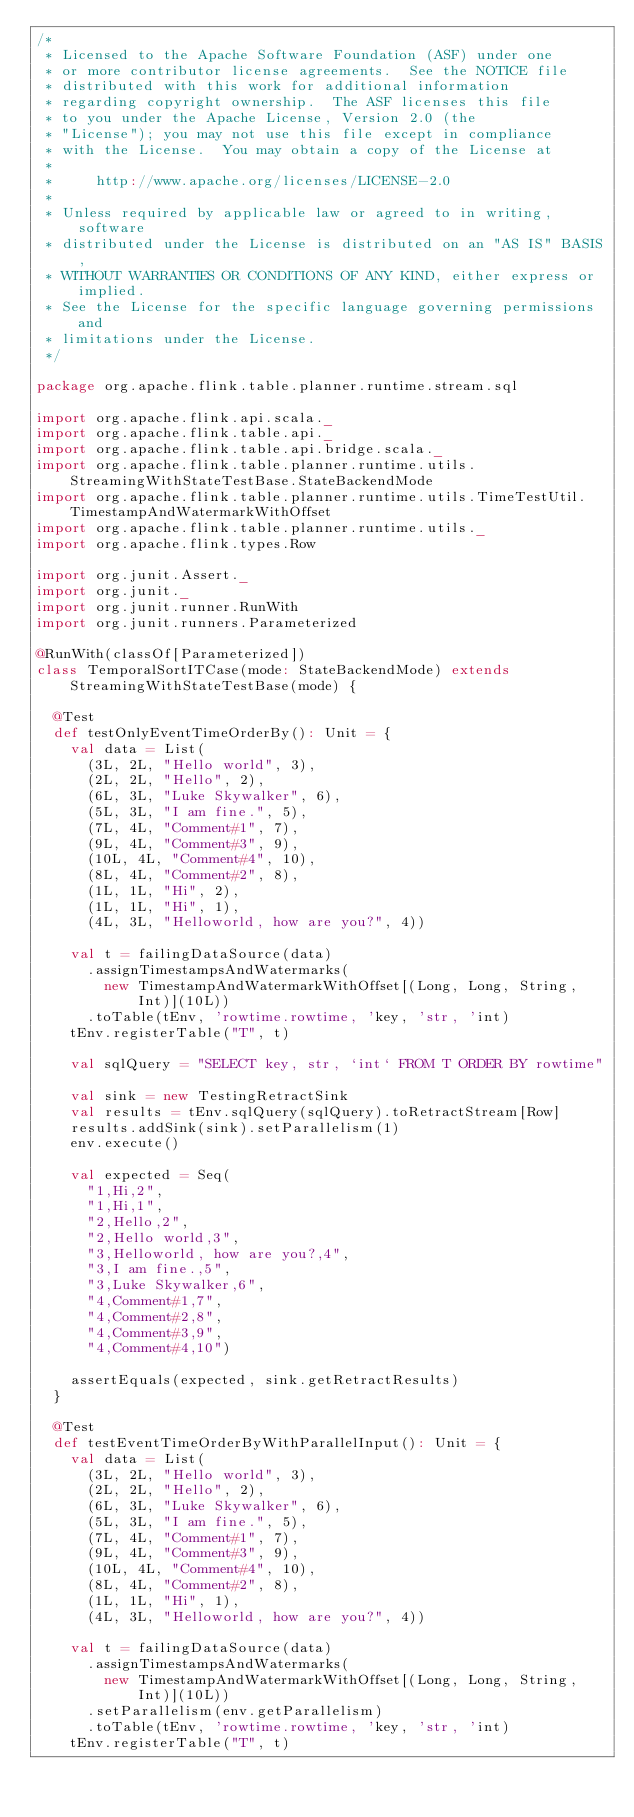<code> <loc_0><loc_0><loc_500><loc_500><_Scala_>/*
 * Licensed to the Apache Software Foundation (ASF) under one
 * or more contributor license agreements.  See the NOTICE file
 * distributed with this work for additional information
 * regarding copyright ownership.  The ASF licenses this file
 * to you under the Apache License, Version 2.0 (the
 * "License"); you may not use this file except in compliance
 * with the License.  You may obtain a copy of the License at
 *
 *     http://www.apache.org/licenses/LICENSE-2.0
 *
 * Unless required by applicable law or agreed to in writing, software
 * distributed under the License is distributed on an "AS IS" BASIS,
 * WITHOUT WARRANTIES OR CONDITIONS OF ANY KIND, either express or implied.
 * See the License for the specific language governing permissions and
 * limitations under the License.
 */

package org.apache.flink.table.planner.runtime.stream.sql

import org.apache.flink.api.scala._
import org.apache.flink.table.api._
import org.apache.flink.table.api.bridge.scala._
import org.apache.flink.table.planner.runtime.utils.StreamingWithStateTestBase.StateBackendMode
import org.apache.flink.table.planner.runtime.utils.TimeTestUtil.TimestampAndWatermarkWithOffset
import org.apache.flink.table.planner.runtime.utils._
import org.apache.flink.types.Row

import org.junit.Assert._
import org.junit._
import org.junit.runner.RunWith
import org.junit.runners.Parameterized

@RunWith(classOf[Parameterized])
class TemporalSortITCase(mode: StateBackendMode) extends StreamingWithStateTestBase(mode) {

  @Test
  def testOnlyEventTimeOrderBy(): Unit = {
    val data = List(
      (3L, 2L, "Hello world", 3),
      (2L, 2L, "Hello", 2),
      (6L, 3L, "Luke Skywalker", 6),
      (5L, 3L, "I am fine.", 5),
      (7L, 4L, "Comment#1", 7),
      (9L, 4L, "Comment#3", 9),
      (10L, 4L, "Comment#4", 10),
      (8L, 4L, "Comment#2", 8),
      (1L, 1L, "Hi", 2),
      (1L, 1L, "Hi", 1),
      (4L, 3L, "Helloworld, how are you?", 4))

    val t = failingDataSource(data)
      .assignTimestampsAndWatermarks(
        new TimestampAndWatermarkWithOffset[(Long, Long, String, Int)](10L))
      .toTable(tEnv, 'rowtime.rowtime, 'key, 'str, 'int)
    tEnv.registerTable("T", t)

    val sqlQuery = "SELECT key, str, `int` FROM T ORDER BY rowtime"

    val sink = new TestingRetractSink
    val results = tEnv.sqlQuery(sqlQuery).toRetractStream[Row]
    results.addSink(sink).setParallelism(1)
    env.execute()

    val expected = Seq(
      "1,Hi,2",
      "1,Hi,1",
      "2,Hello,2",
      "2,Hello world,3",
      "3,Helloworld, how are you?,4",
      "3,I am fine.,5",
      "3,Luke Skywalker,6",
      "4,Comment#1,7",
      "4,Comment#2,8",
      "4,Comment#3,9",
      "4,Comment#4,10")

    assertEquals(expected, sink.getRetractResults)
  }

  @Test
  def testEventTimeOrderByWithParallelInput(): Unit = {
    val data = List(
      (3L, 2L, "Hello world", 3),
      (2L, 2L, "Hello", 2),
      (6L, 3L, "Luke Skywalker", 6),
      (5L, 3L, "I am fine.", 5),
      (7L, 4L, "Comment#1", 7),
      (9L, 4L, "Comment#3", 9),
      (10L, 4L, "Comment#4", 10),
      (8L, 4L, "Comment#2", 8),
      (1L, 1L, "Hi", 1),
      (4L, 3L, "Helloworld, how are you?", 4))

    val t = failingDataSource(data)
      .assignTimestampsAndWatermarks(
        new TimestampAndWatermarkWithOffset[(Long, Long, String, Int)](10L))
      .setParallelism(env.getParallelism)
      .toTable(tEnv, 'rowtime.rowtime, 'key, 'str, 'int)
    tEnv.registerTable("T", t)
</code> 